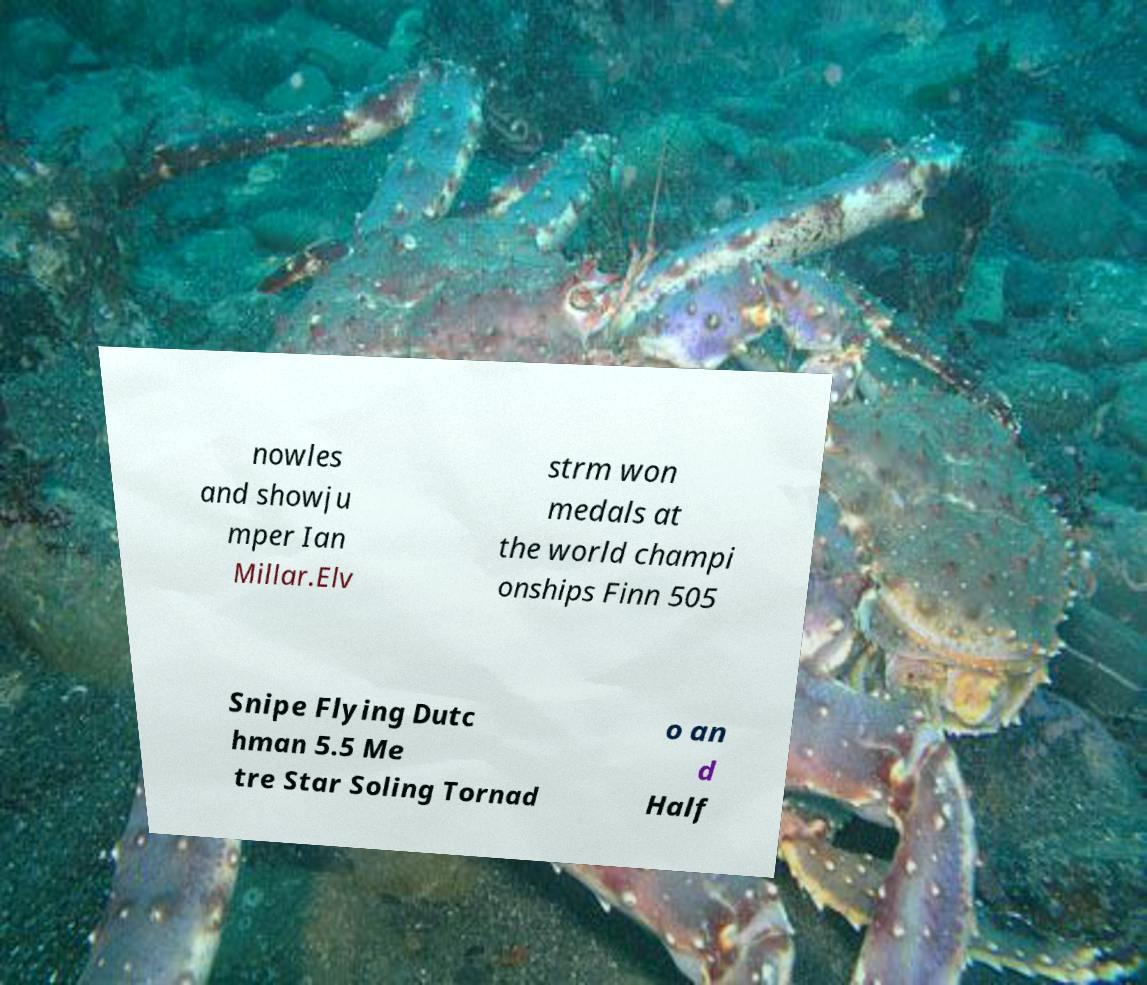Could you assist in decoding the text presented in this image and type it out clearly? nowles and showju mper Ian Millar.Elv strm won medals at the world champi onships Finn 505 Snipe Flying Dutc hman 5.5 Me tre Star Soling Tornad o an d Half 